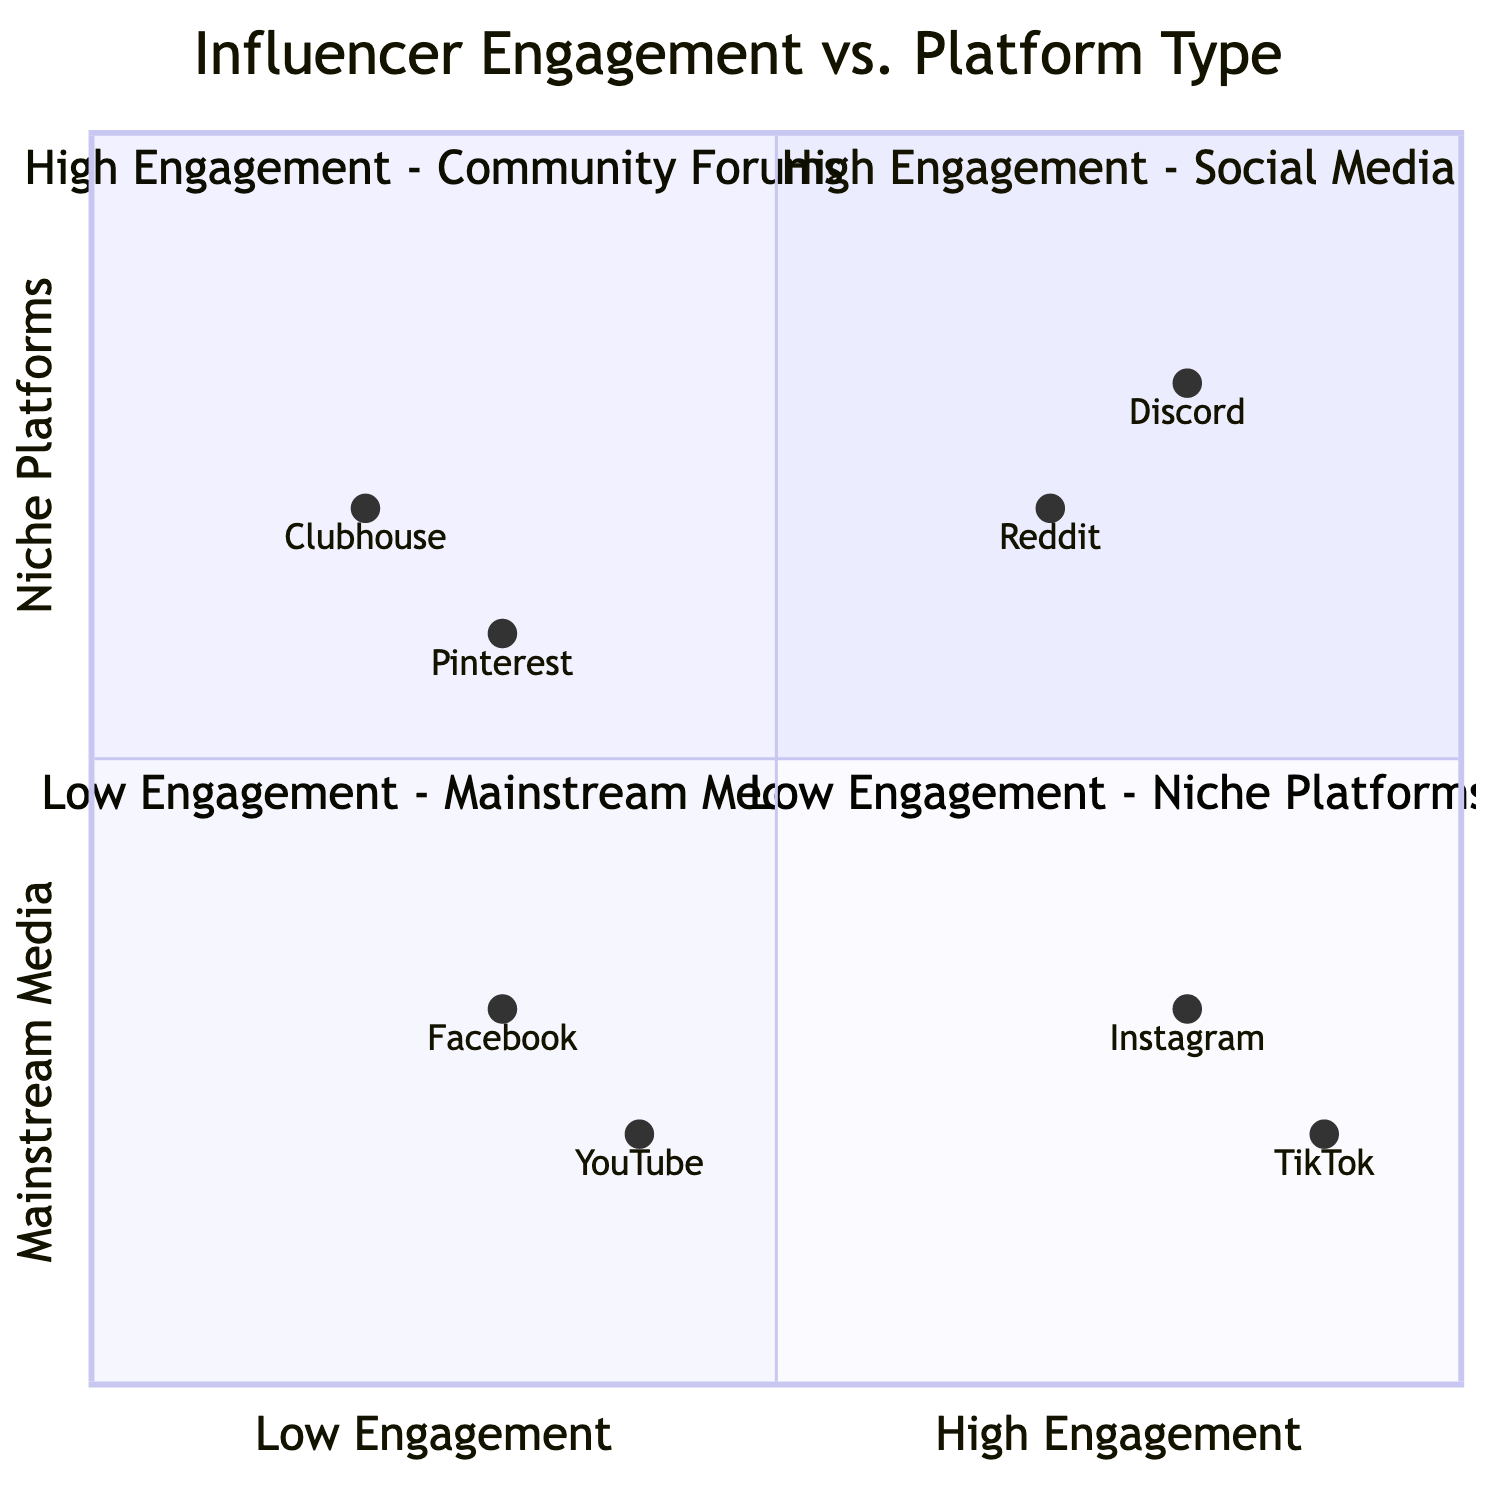What platforms are in the "High Engagement - Social Media" quadrant? The "High Engagement - Social Media" quadrant contains Instagram and TikTok. By examining the entities listed in this quadrant, we can readily identify these two platforms mentioned.
Answer: Instagram, TikTok Which platform has the highest engagement score? The highest engagement score is represented by TikTok, which is located at [0.9, 0.2] in the chart. This is determined by comparing the engagement scores of all platforms on the x-axis where higher values indicate more engagement.
Answer: TikTok How many platforms are categorized under "Low Engagement - Niche Platforms"? There are two platforms categorized under "Low Engagement - Niche Platforms": Clubhouse and Pinterest. This can be verified by counting the entities listed in this quadrant.
Answer: Two What age range is associated with Discord? The age range associated with Discord is 16-30 years old. This information is found in the demographic description for the platform, which outlines the typical user age range.
Answer: 16-30 years old Which quadrant has the most diverse user age demographics? The "High Engagement - Community Forums" quadrant includes Reddit and Discord, indicating diverse interests and age ranges. Here, both platforms have users with varying demographics that cover a broad spectrum.
Answer: High Engagement - Community Forums What type of content does Clubhouse focus on? Clubhouse focuses on audio-based content, as stated in its demographic description. This is specifically mentioned in the entity attributes under "Low Engagement - Niche Platforms."
Answer: Audio-focused content Which platform occupies a position on the lower end of both engagement and niche within the diagram? Clubhouse occupies a position on the lower end of both engagement and niche, placed in the quadrant of "Low Engagement - Niche Platforms," which has a lower engagement score compared to others.
Answer: Clubhouse Which platform is considered to have low engagement but covers all ages? YouTube is considered to have low engagement while covering all ages, as highlighted in the demographic information that states its wide content variety and all-age audience.
Answer: YouTube In which quadrant is Reddit located? Reddit is located in the "High Engagement - Community Forums" quadrant, which is derived from the information that identifies it as part of a group characterized by high user engagement and active discussions.
Answer: High Engagement - Community Forums 